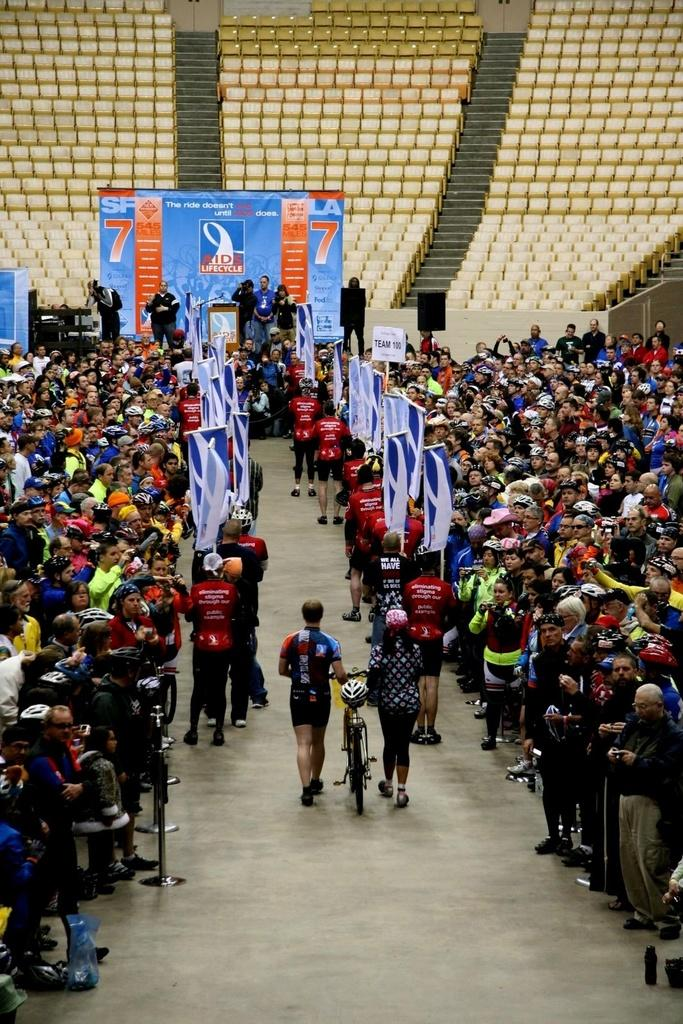What can be seen in the image in terms of people? There are groups of people in the image. What else is present in the image besides people? There are banners, a bicycle, stairs, and chairs in the image. Can you tell me how many hens are sitting on the chairs in the image? There are no hens present in the image; it features groups of people, banners, a bicycle, stairs, and chairs. What type of act is being performed by the people in the image? The image does not depict any specific act being performed by the people; they are simply standing or sitting in groups. 